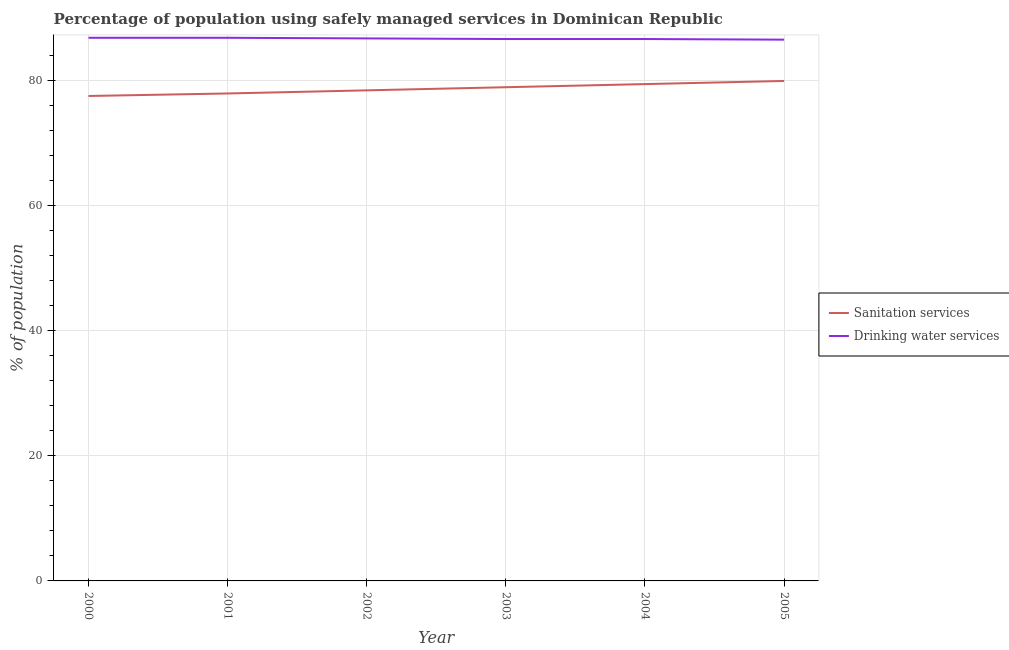Is the number of lines equal to the number of legend labels?
Make the answer very short. Yes. What is the percentage of population who used drinking water services in 2004?
Your answer should be compact. 86.6. Across all years, what is the maximum percentage of population who used sanitation services?
Ensure brevity in your answer.  79.9. Across all years, what is the minimum percentage of population who used drinking water services?
Make the answer very short. 86.5. In which year was the percentage of population who used drinking water services maximum?
Ensure brevity in your answer.  2000. In which year was the percentage of population who used drinking water services minimum?
Your answer should be compact. 2005. What is the total percentage of population who used sanitation services in the graph?
Your response must be concise. 472. What is the difference between the percentage of population who used sanitation services in 2000 and the percentage of population who used drinking water services in 2001?
Provide a short and direct response. -9.3. What is the average percentage of population who used sanitation services per year?
Your answer should be very brief. 78.67. In the year 2004, what is the difference between the percentage of population who used sanitation services and percentage of population who used drinking water services?
Offer a terse response. -7.2. In how many years, is the percentage of population who used sanitation services greater than 44 %?
Make the answer very short. 6. What is the ratio of the percentage of population who used drinking water services in 2001 to that in 2005?
Provide a succinct answer. 1. Is the difference between the percentage of population who used sanitation services in 2001 and 2004 greater than the difference between the percentage of population who used drinking water services in 2001 and 2004?
Offer a very short reply. No. What is the difference between the highest and the second highest percentage of population who used sanitation services?
Keep it short and to the point. 0.5. What is the difference between the highest and the lowest percentage of population who used sanitation services?
Give a very brief answer. 2.4. In how many years, is the percentage of population who used sanitation services greater than the average percentage of population who used sanitation services taken over all years?
Your answer should be compact. 3. Is the sum of the percentage of population who used drinking water services in 2004 and 2005 greater than the maximum percentage of population who used sanitation services across all years?
Offer a terse response. Yes. Does the percentage of population who used sanitation services monotonically increase over the years?
Offer a terse response. Yes. Is the percentage of population who used sanitation services strictly greater than the percentage of population who used drinking water services over the years?
Ensure brevity in your answer.  No. How many lines are there?
Provide a succinct answer. 2. Are the values on the major ticks of Y-axis written in scientific E-notation?
Your response must be concise. No. Does the graph contain any zero values?
Ensure brevity in your answer.  No. Where does the legend appear in the graph?
Provide a short and direct response. Center right. How are the legend labels stacked?
Keep it short and to the point. Vertical. What is the title of the graph?
Ensure brevity in your answer.  Percentage of population using safely managed services in Dominican Republic. What is the label or title of the Y-axis?
Provide a short and direct response. % of population. What is the % of population in Sanitation services in 2000?
Offer a very short reply. 77.5. What is the % of population of Drinking water services in 2000?
Offer a terse response. 86.8. What is the % of population of Sanitation services in 2001?
Offer a terse response. 77.9. What is the % of population in Drinking water services in 2001?
Ensure brevity in your answer.  86.8. What is the % of population of Sanitation services in 2002?
Your response must be concise. 78.4. What is the % of population of Drinking water services in 2002?
Your answer should be very brief. 86.7. What is the % of population of Sanitation services in 2003?
Your answer should be compact. 78.9. What is the % of population of Drinking water services in 2003?
Your answer should be very brief. 86.6. What is the % of population in Sanitation services in 2004?
Your answer should be very brief. 79.4. What is the % of population in Drinking water services in 2004?
Offer a very short reply. 86.6. What is the % of population of Sanitation services in 2005?
Provide a succinct answer. 79.9. What is the % of population in Drinking water services in 2005?
Provide a short and direct response. 86.5. Across all years, what is the maximum % of population in Sanitation services?
Your answer should be compact. 79.9. Across all years, what is the maximum % of population of Drinking water services?
Your response must be concise. 86.8. Across all years, what is the minimum % of population of Sanitation services?
Your answer should be compact. 77.5. Across all years, what is the minimum % of population in Drinking water services?
Keep it short and to the point. 86.5. What is the total % of population in Sanitation services in the graph?
Ensure brevity in your answer.  472. What is the total % of population in Drinking water services in the graph?
Keep it short and to the point. 520. What is the difference between the % of population of Drinking water services in 2000 and that in 2002?
Your answer should be very brief. 0.1. What is the difference between the % of population in Sanitation services in 2000 and that in 2003?
Offer a very short reply. -1.4. What is the difference between the % of population in Drinking water services in 2000 and that in 2003?
Keep it short and to the point. 0.2. What is the difference between the % of population in Drinking water services in 2000 and that in 2004?
Make the answer very short. 0.2. What is the difference between the % of population in Sanitation services in 2001 and that in 2002?
Ensure brevity in your answer.  -0.5. What is the difference between the % of population of Drinking water services in 2001 and that in 2002?
Offer a very short reply. 0.1. What is the difference between the % of population in Sanitation services in 2001 and that in 2003?
Offer a terse response. -1. What is the difference between the % of population in Drinking water services in 2001 and that in 2003?
Ensure brevity in your answer.  0.2. What is the difference between the % of population of Drinking water services in 2001 and that in 2004?
Keep it short and to the point. 0.2. What is the difference between the % of population in Sanitation services in 2001 and that in 2005?
Your answer should be compact. -2. What is the difference between the % of population in Sanitation services in 2002 and that in 2003?
Provide a succinct answer. -0.5. What is the difference between the % of population of Drinking water services in 2002 and that in 2003?
Provide a short and direct response. 0.1. What is the difference between the % of population in Sanitation services in 2002 and that in 2005?
Your response must be concise. -1.5. What is the difference between the % of population of Sanitation services in 2003 and that in 2005?
Your answer should be very brief. -1. What is the difference between the % of population in Drinking water services in 2003 and that in 2005?
Ensure brevity in your answer.  0.1. What is the difference between the % of population of Drinking water services in 2004 and that in 2005?
Offer a very short reply. 0.1. What is the difference between the % of population of Sanitation services in 2003 and the % of population of Drinking water services in 2005?
Offer a very short reply. -7.6. What is the average % of population of Sanitation services per year?
Make the answer very short. 78.67. What is the average % of population in Drinking water services per year?
Make the answer very short. 86.67. In the year 2000, what is the difference between the % of population of Sanitation services and % of population of Drinking water services?
Provide a succinct answer. -9.3. In the year 2002, what is the difference between the % of population in Sanitation services and % of population in Drinking water services?
Provide a succinct answer. -8.3. In the year 2003, what is the difference between the % of population in Sanitation services and % of population in Drinking water services?
Ensure brevity in your answer.  -7.7. In the year 2004, what is the difference between the % of population in Sanitation services and % of population in Drinking water services?
Provide a succinct answer. -7.2. In the year 2005, what is the difference between the % of population of Sanitation services and % of population of Drinking water services?
Your response must be concise. -6.6. What is the ratio of the % of population of Sanitation services in 2000 to that in 2001?
Give a very brief answer. 0.99. What is the ratio of the % of population in Drinking water services in 2000 to that in 2001?
Provide a short and direct response. 1. What is the ratio of the % of population in Drinking water services in 2000 to that in 2002?
Your response must be concise. 1. What is the ratio of the % of population in Sanitation services in 2000 to that in 2003?
Provide a short and direct response. 0.98. What is the ratio of the % of population in Sanitation services in 2000 to that in 2004?
Your answer should be very brief. 0.98. What is the ratio of the % of population of Drinking water services in 2000 to that in 2004?
Offer a very short reply. 1. What is the ratio of the % of population of Sanitation services in 2000 to that in 2005?
Keep it short and to the point. 0.97. What is the ratio of the % of population of Drinking water services in 2000 to that in 2005?
Give a very brief answer. 1. What is the ratio of the % of population in Drinking water services in 2001 to that in 2002?
Offer a very short reply. 1. What is the ratio of the % of population in Sanitation services in 2001 to that in 2003?
Ensure brevity in your answer.  0.99. What is the ratio of the % of population of Drinking water services in 2001 to that in 2003?
Provide a succinct answer. 1. What is the ratio of the % of population of Sanitation services in 2001 to that in 2004?
Make the answer very short. 0.98. What is the ratio of the % of population in Drinking water services in 2001 to that in 2005?
Your response must be concise. 1. What is the ratio of the % of population in Sanitation services in 2002 to that in 2003?
Your response must be concise. 0.99. What is the ratio of the % of population in Sanitation services in 2002 to that in 2004?
Your answer should be very brief. 0.99. What is the ratio of the % of population in Drinking water services in 2002 to that in 2004?
Give a very brief answer. 1. What is the ratio of the % of population of Sanitation services in 2002 to that in 2005?
Ensure brevity in your answer.  0.98. What is the ratio of the % of population of Sanitation services in 2003 to that in 2004?
Make the answer very short. 0.99. What is the ratio of the % of population of Drinking water services in 2003 to that in 2004?
Your response must be concise. 1. What is the ratio of the % of population of Sanitation services in 2003 to that in 2005?
Your answer should be very brief. 0.99. What is the ratio of the % of population of Sanitation services in 2004 to that in 2005?
Ensure brevity in your answer.  0.99. What is the ratio of the % of population of Drinking water services in 2004 to that in 2005?
Your response must be concise. 1. What is the difference between the highest and the second highest % of population of Sanitation services?
Offer a terse response. 0.5. What is the difference between the highest and the lowest % of population in Sanitation services?
Give a very brief answer. 2.4. What is the difference between the highest and the lowest % of population in Drinking water services?
Ensure brevity in your answer.  0.3. 